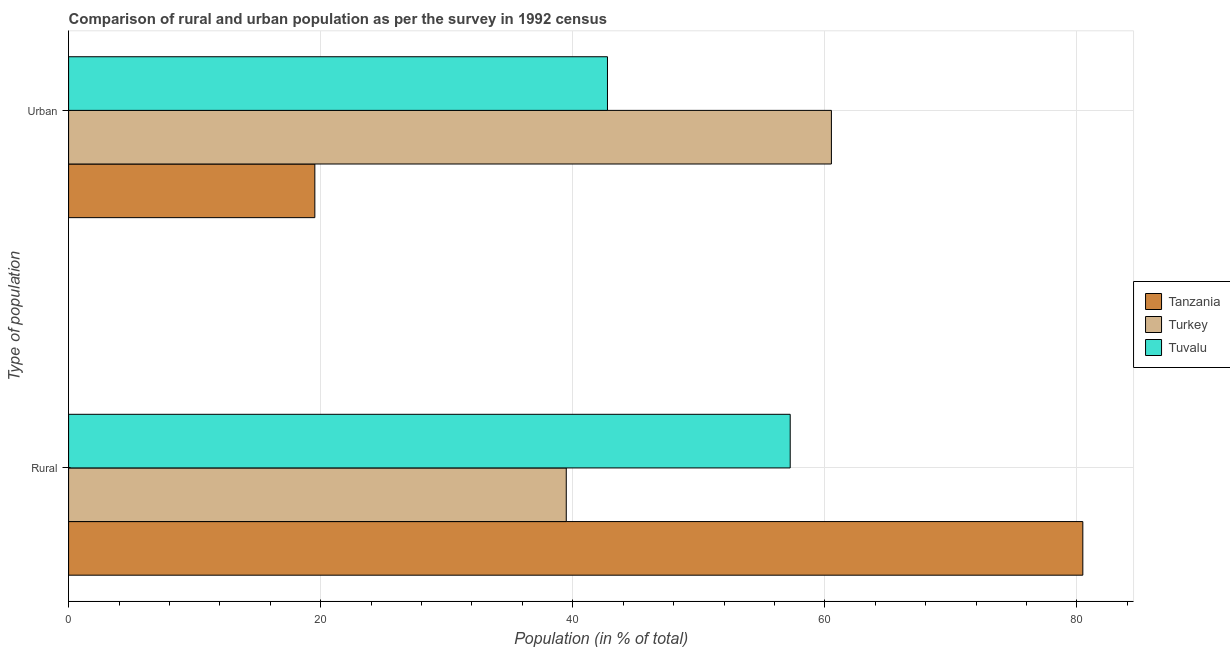How many groups of bars are there?
Ensure brevity in your answer.  2. How many bars are there on the 1st tick from the top?
Your answer should be compact. 3. What is the label of the 1st group of bars from the top?
Make the answer very short. Urban. What is the rural population in Turkey?
Offer a very short reply. 39.48. Across all countries, what is the maximum rural population?
Ensure brevity in your answer.  80.46. Across all countries, what is the minimum urban population?
Your response must be concise. 19.54. In which country was the rural population maximum?
Offer a terse response. Tanzania. What is the total rural population in the graph?
Make the answer very short. 177.19. What is the difference between the urban population in Tanzania and that in Turkey?
Offer a terse response. -40.98. What is the difference between the urban population in Turkey and the rural population in Tanzania?
Give a very brief answer. -19.95. What is the average urban population per country?
Give a very brief answer. 40.94. What is the difference between the urban population and rural population in Tuvalu?
Give a very brief answer. -14.5. What is the ratio of the urban population in Turkey to that in Tanzania?
Offer a very short reply. 3.1. What does the 3rd bar from the top in Urban represents?
Provide a short and direct response. Tanzania. What does the 3rd bar from the bottom in Rural represents?
Give a very brief answer. Tuvalu. Does the graph contain any zero values?
Make the answer very short. No. What is the title of the graph?
Keep it short and to the point. Comparison of rural and urban population as per the survey in 1992 census. What is the label or title of the X-axis?
Your answer should be very brief. Population (in % of total). What is the label or title of the Y-axis?
Provide a succinct answer. Type of population. What is the Population (in % of total) of Tanzania in Rural?
Offer a terse response. 80.46. What is the Population (in % of total) in Turkey in Rural?
Give a very brief answer. 39.48. What is the Population (in % of total) in Tuvalu in Rural?
Give a very brief answer. 57.25. What is the Population (in % of total) in Tanzania in Urban?
Your answer should be compact. 19.54. What is the Population (in % of total) in Turkey in Urban?
Keep it short and to the point. 60.52. What is the Population (in % of total) of Tuvalu in Urban?
Your response must be concise. 42.75. Across all Type of population, what is the maximum Population (in % of total) of Tanzania?
Give a very brief answer. 80.46. Across all Type of population, what is the maximum Population (in % of total) of Turkey?
Offer a very short reply. 60.52. Across all Type of population, what is the maximum Population (in % of total) of Tuvalu?
Keep it short and to the point. 57.25. Across all Type of population, what is the minimum Population (in % of total) of Tanzania?
Keep it short and to the point. 19.54. Across all Type of population, what is the minimum Population (in % of total) in Turkey?
Your answer should be very brief. 39.48. Across all Type of population, what is the minimum Population (in % of total) of Tuvalu?
Your response must be concise. 42.75. What is the total Population (in % of total) in Tanzania in the graph?
Your answer should be compact. 100. What is the total Population (in % of total) in Turkey in the graph?
Keep it short and to the point. 100. What is the total Population (in % of total) in Tuvalu in the graph?
Provide a succinct answer. 100. What is the difference between the Population (in % of total) of Tanzania in Rural and that in Urban?
Offer a very short reply. 60.93. What is the difference between the Population (in % of total) in Turkey in Rural and that in Urban?
Offer a terse response. -21.04. What is the difference between the Population (in % of total) in Tuvalu in Rural and that in Urban?
Ensure brevity in your answer.  14.5. What is the difference between the Population (in % of total) in Tanzania in Rural and the Population (in % of total) in Turkey in Urban?
Give a very brief answer. 19.95. What is the difference between the Population (in % of total) of Tanzania in Rural and the Population (in % of total) of Tuvalu in Urban?
Keep it short and to the point. 37.71. What is the difference between the Population (in % of total) in Turkey in Rural and the Population (in % of total) in Tuvalu in Urban?
Your response must be concise. -3.27. What is the average Population (in % of total) of Turkey per Type of population?
Offer a very short reply. 50. What is the difference between the Population (in % of total) of Tanzania and Population (in % of total) of Turkey in Rural?
Ensure brevity in your answer.  40.98. What is the difference between the Population (in % of total) in Tanzania and Population (in % of total) in Tuvalu in Rural?
Keep it short and to the point. 23.21. What is the difference between the Population (in % of total) of Turkey and Population (in % of total) of Tuvalu in Rural?
Your response must be concise. -17.77. What is the difference between the Population (in % of total) of Tanzania and Population (in % of total) of Turkey in Urban?
Make the answer very short. -40.98. What is the difference between the Population (in % of total) of Tanzania and Population (in % of total) of Tuvalu in Urban?
Your answer should be compact. -23.21. What is the difference between the Population (in % of total) in Turkey and Population (in % of total) in Tuvalu in Urban?
Offer a very short reply. 17.77. What is the ratio of the Population (in % of total) in Tanzania in Rural to that in Urban?
Offer a very short reply. 4.12. What is the ratio of the Population (in % of total) of Turkey in Rural to that in Urban?
Ensure brevity in your answer.  0.65. What is the ratio of the Population (in % of total) in Tuvalu in Rural to that in Urban?
Your answer should be compact. 1.34. What is the difference between the highest and the second highest Population (in % of total) of Tanzania?
Ensure brevity in your answer.  60.93. What is the difference between the highest and the second highest Population (in % of total) in Turkey?
Give a very brief answer. 21.04. What is the difference between the highest and the second highest Population (in % of total) in Tuvalu?
Provide a succinct answer. 14.5. What is the difference between the highest and the lowest Population (in % of total) of Tanzania?
Offer a terse response. 60.93. What is the difference between the highest and the lowest Population (in % of total) of Turkey?
Your answer should be compact. 21.04. What is the difference between the highest and the lowest Population (in % of total) of Tuvalu?
Provide a short and direct response. 14.5. 